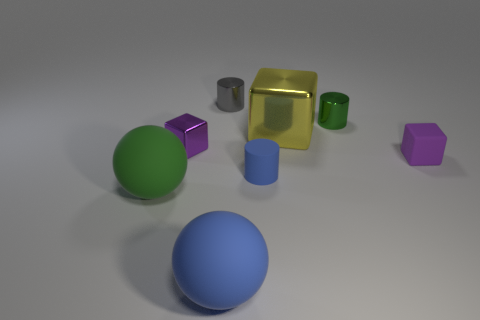Add 1 tiny blue cylinders. How many objects exist? 9 Subtract all cylinders. How many objects are left? 5 Add 7 tiny purple balls. How many tiny purple balls exist? 7 Subtract 0 red cubes. How many objects are left? 8 Subtract all red spheres. Subtract all purple matte blocks. How many objects are left? 7 Add 6 purple cubes. How many purple cubes are left? 8 